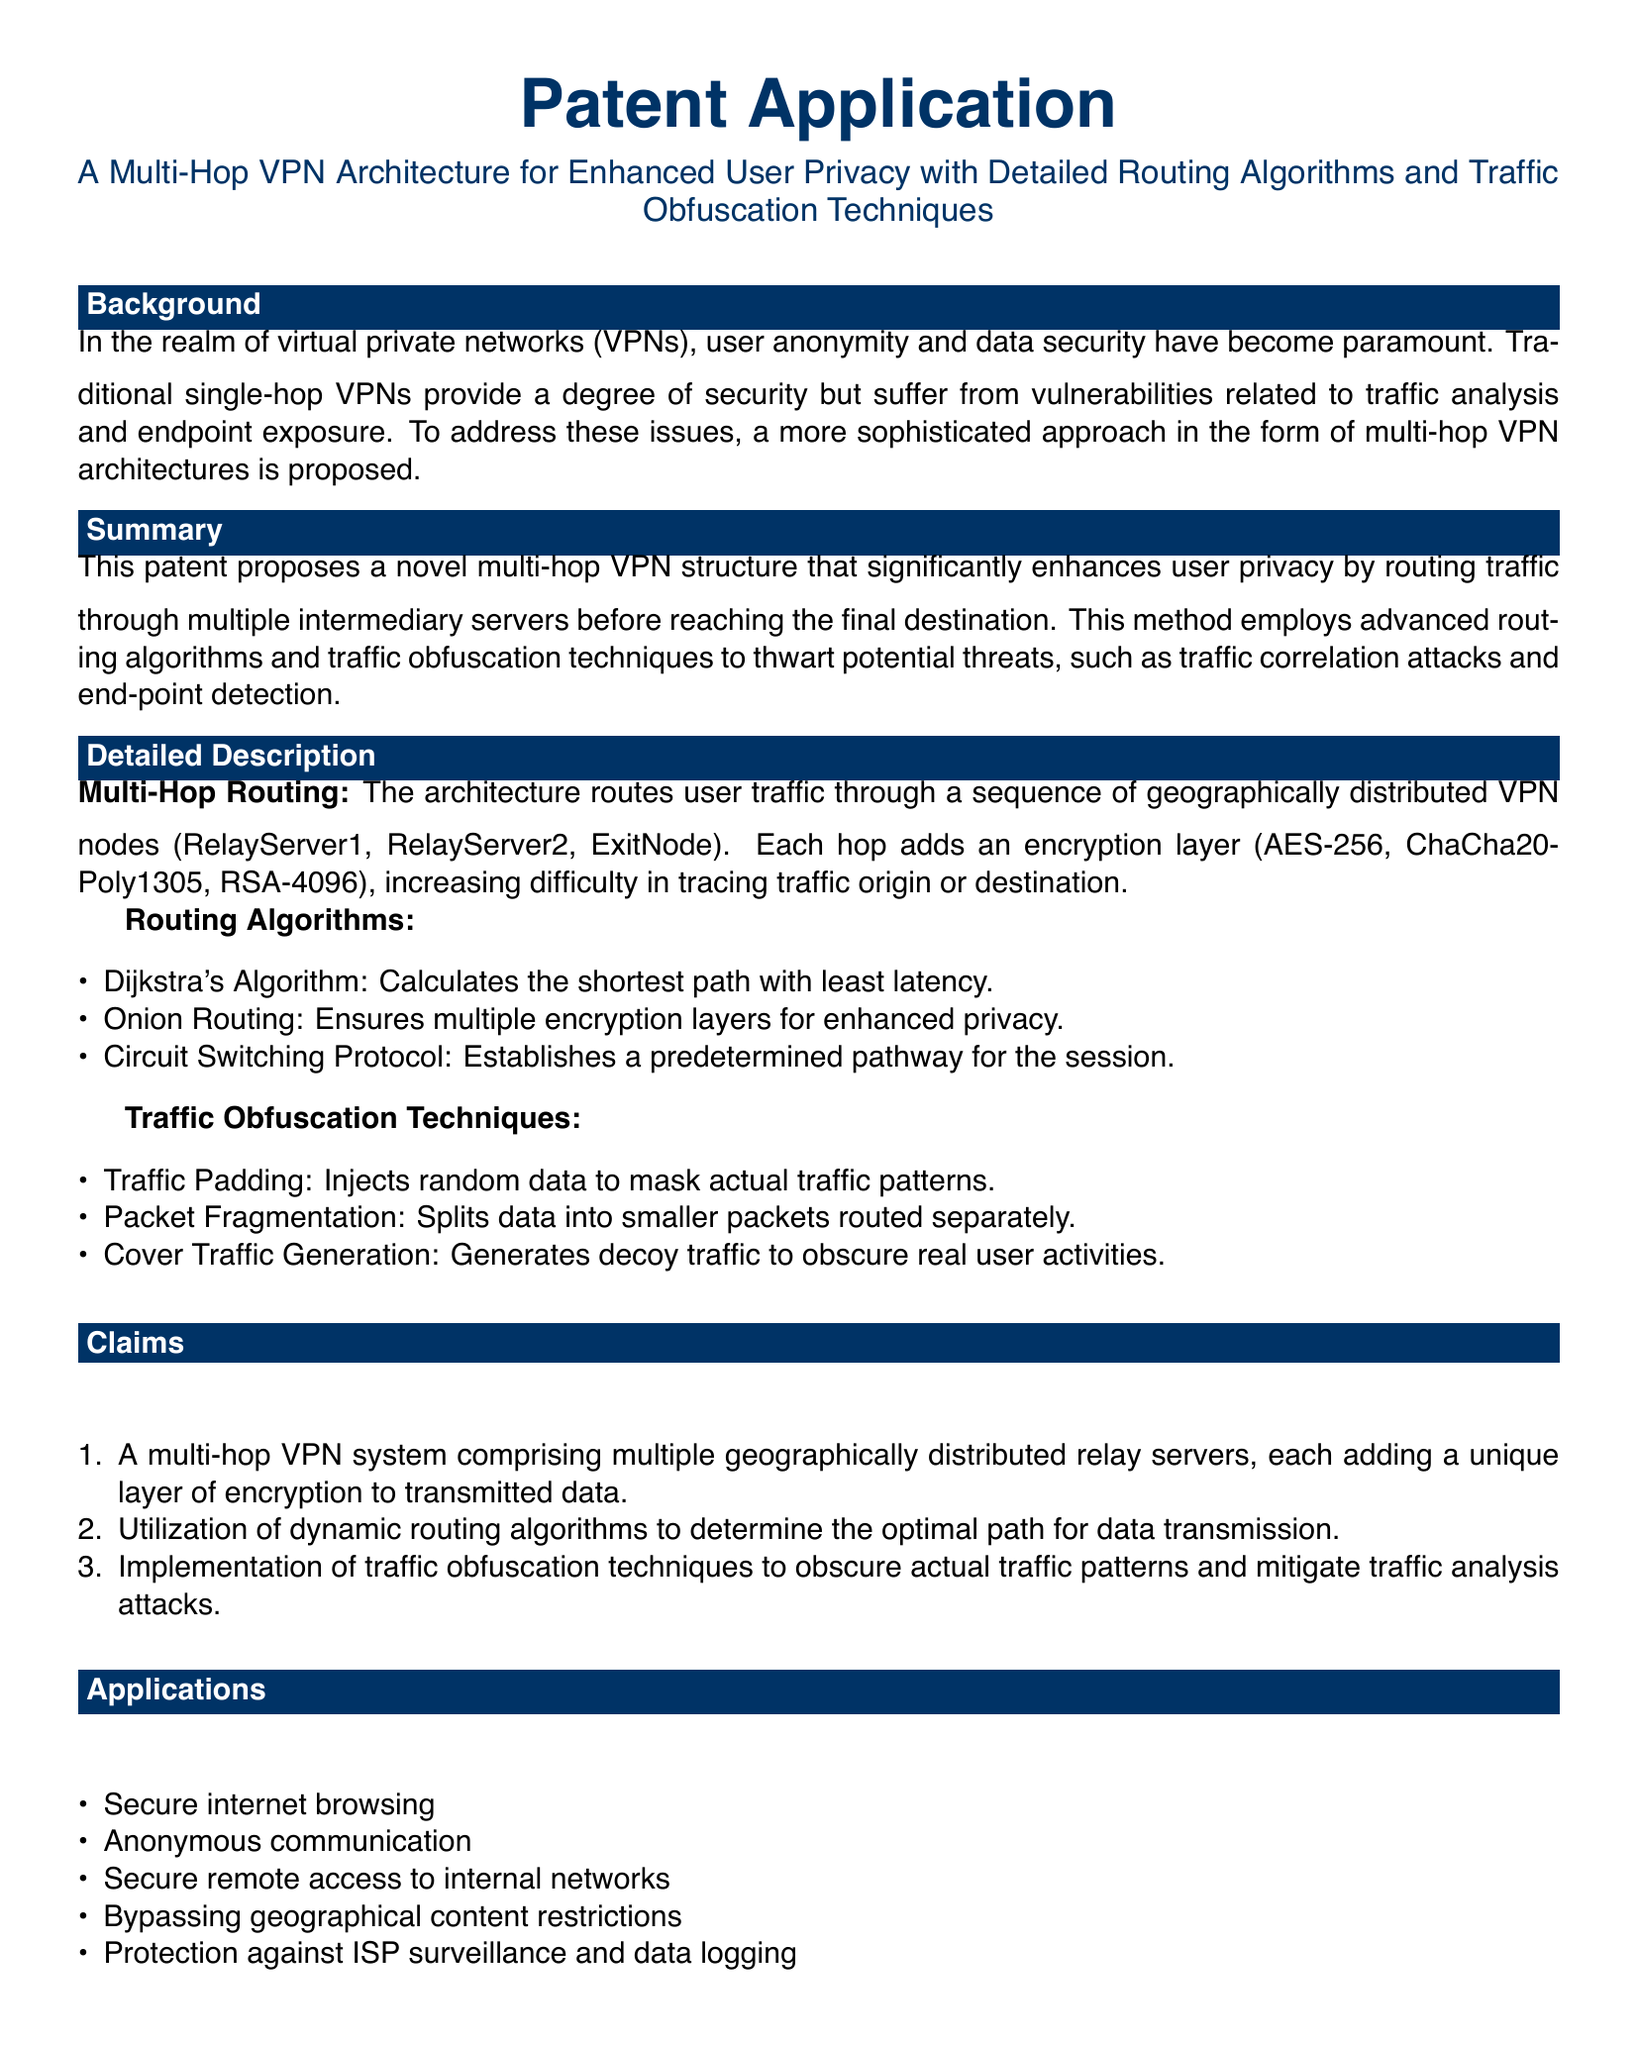What are the encryption methods used in the multi-hop VPN architecture? The document lists the encryption methods including AES-256, ChaCha20-Poly1305, and RSA-4096 used in the multi-hop VPN architecture.
Answer: AES-256, ChaCha20-Poly1305, RSA-4096 What is the primary benefit of the proposed multi-hop VPN? The document states that the primary benefit is enhanced user privacy by routing traffic through multiple intermediary servers.
Answer: Enhanced user privacy What routing algorithm ensures multiple encryption layers? The document identifies Onion Routing as the algorithm that ensures multiple encryption layers for enhanced privacy.
Answer: Onion Routing How many claims are made in the patent application? The document enumerates three claims regarding the multi-hop VPN system, routing algorithms, and traffic obfuscation techniques.
Answer: Three What type of traffic obfuscation technique injects random data? The document specifies that Traffic Padding is the technique that injects random data to mask actual traffic patterns.
Answer: Traffic Padding Which application involves bypassing geographical content restrictions? The document lists “Bypassing geographical content restrictions” as one of the applications of the proposed multi-hop VPN architecture.
Answer: Bypassing geographical content restrictions What is the purpose of cover traffic generation? The document explains that cover traffic generation is used to generate decoy traffic to obscure real user activities.
Answer: To obscure real user activities What is the maximum allowable margin set in the document? The document indicates that the margin is set at one centimeter.
Answer: One centimeter 